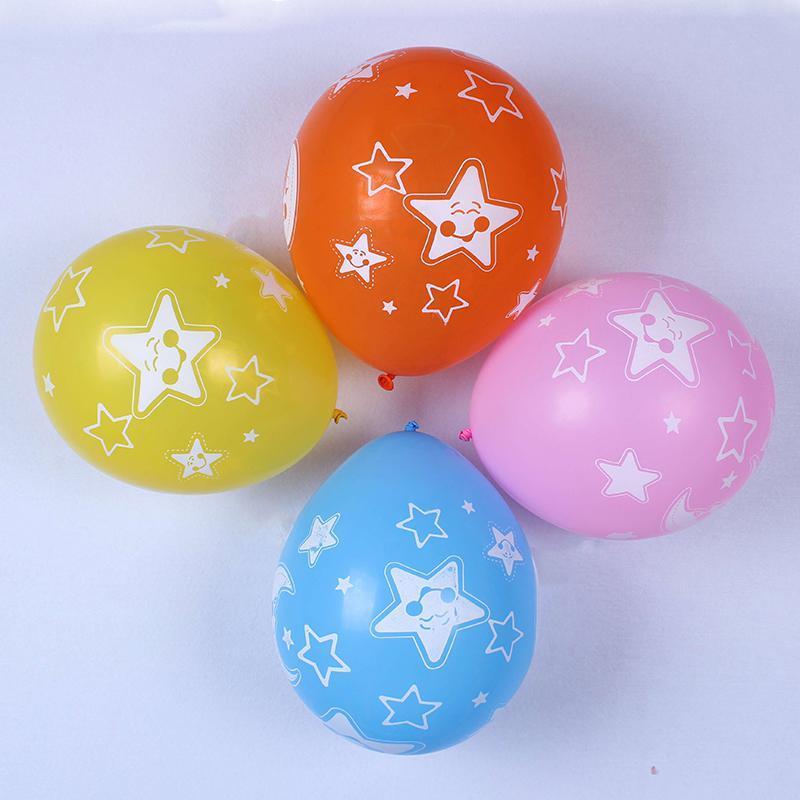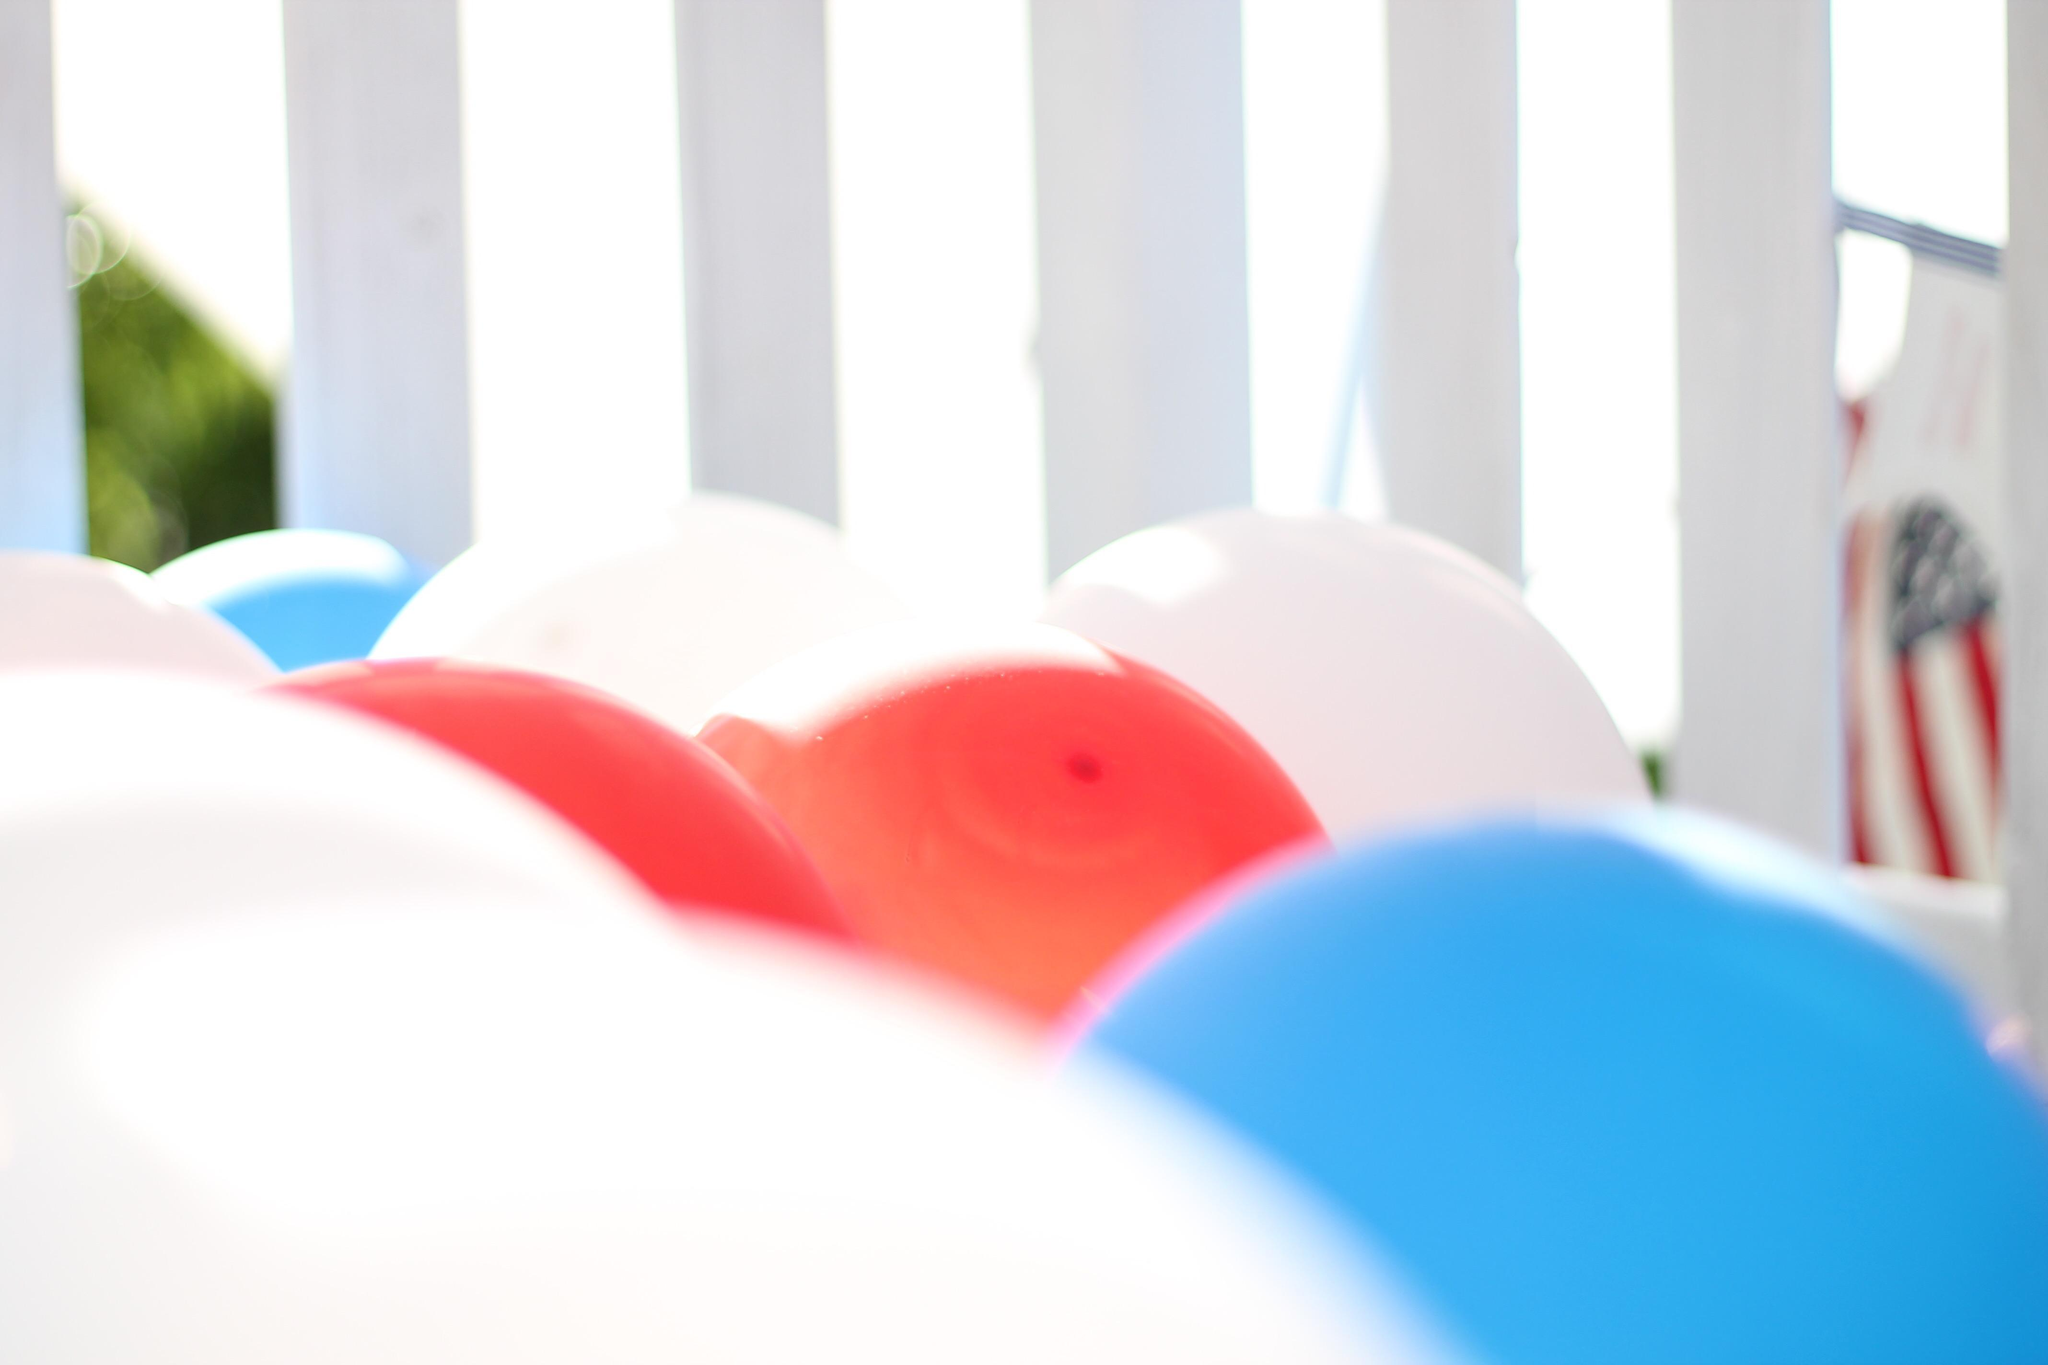The first image is the image on the left, the second image is the image on the right. Analyze the images presented: Is the assertion "IN at least one image there is a single star balloon." valid? Answer yes or no. No. The first image is the image on the left, the second image is the image on the right. For the images displayed, is the sentence "Each image includes at least one star-shaped balloon, and at least one image includes multiple colors of star balloons, including gold, green, red, and blue." factually correct? Answer yes or no. No. 